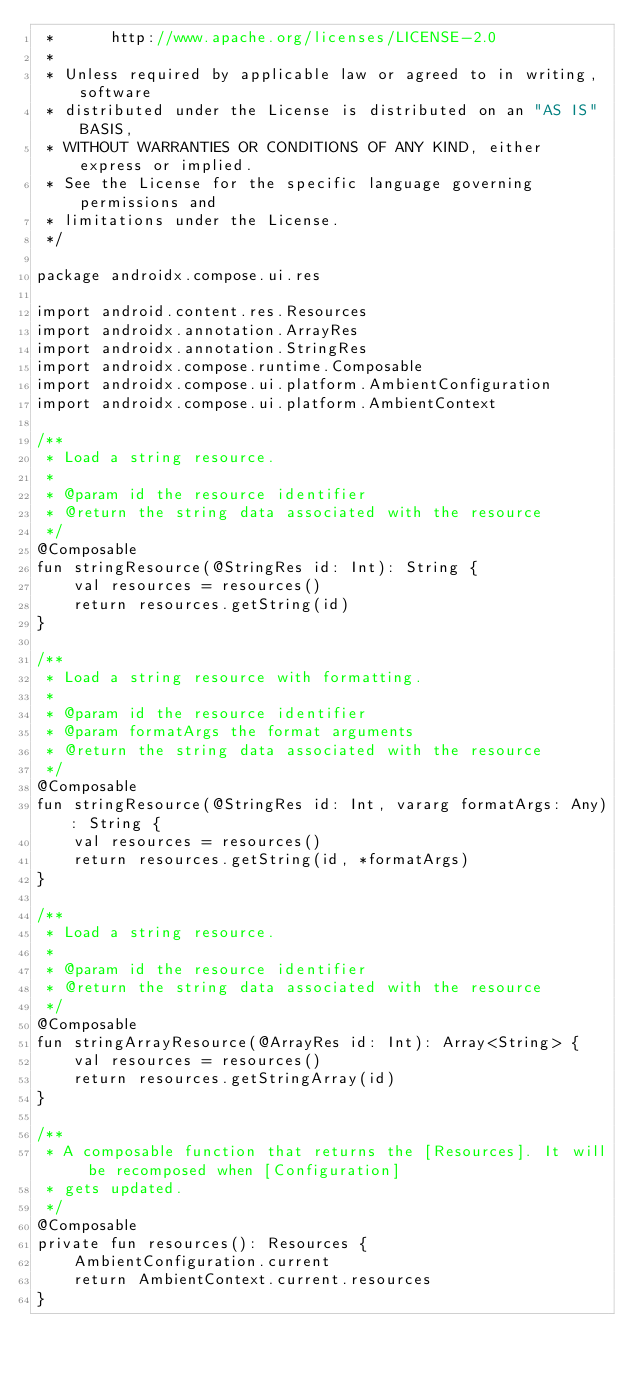<code> <loc_0><loc_0><loc_500><loc_500><_Kotlin_> *      http://www.apache.org/licenses/LICENSE-2.0
 *
 * Unless required by applicable law or agreed to in writing, software
 * distributed under the License is distributed on an "AS IS" BASIS,
 * WITHOUT WARRANTIES OR CONDITIONS OF ANY KIND, either express or implied.
 * See the License for the specific language governing permissions and
 * limitations under the License.
 */

package androidx.compose.ui.res

import android.content.res.Resources
import androidx.annotation.ArrayRes
import androidx.annotation.StringRes
import androidx.compose.runtime.Composable
import androidx.compose.ui.platform.AmbientConfiguration
import androidx.compose.ui.platform.AmbientContext

/**
 * Load a string resource.
 *
 * @param id the resource identifier
 * @return the string data associated with the resource
 */
@Composable
fun stringResource(@StringRes id: Int): String {
    val resources = resources()
    return resources.getString(id)
}

/**
 * Load a string resource with formatting.
 *
 * @param id the resource identifier
 * @param formatArgs the format arguments
 * @return the string data associated with the resource
 */
@Composable
fun stringResource(@StringRes id: Int, vararg formatArgs: Any): String {
    val resources = resources()
    return resources.getString(id, *formatArgs)
}

/**
 * Load a string resource.
 *
 * @param id the resource identifier
 * @return the string data associated with the resource
 */
@Composable
fun stringArrayResource(@ArrayRes id: Int): Array<String> {
    val resources = resources()
    return resources.getStringArray(id)
}

/**
 * A composable function that returns the [Resources]. It will be recomposed when [Configuration]
 * gets updated.
 */
@Composable
private fun resources(): Resources {
    AmbientConfiguration.current
    return AmbientContext.current.resources
}
</code> 